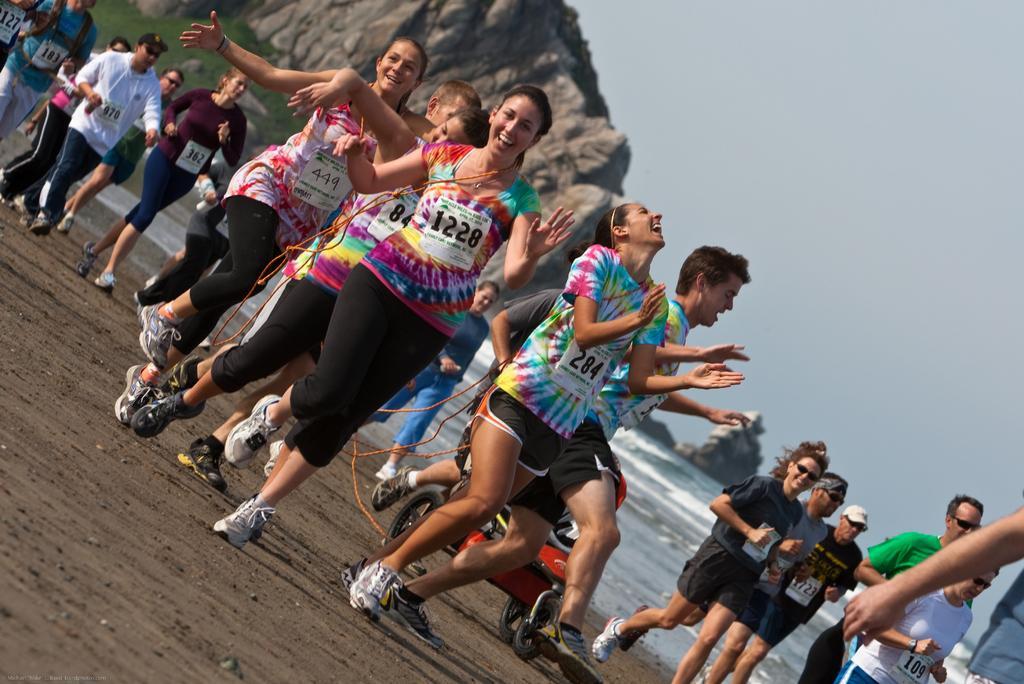Can you describe this image briefly? In this image we can see persons running on the ground. In the background we can see hill, rock, water, sky and grass. 